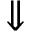<formula> <loc_0><loc_0><loc_500><loc_500>\Downarrow</formula> 